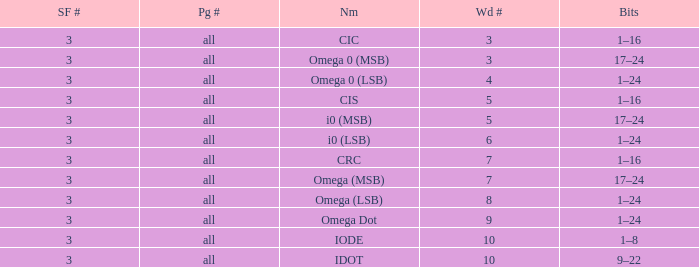What is the word count that is named omega dot? 9.0. 